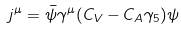Convert formula to latex. <formula><loc_0><loc_0><loc_500><loc_500>j ^ { \mu } = \bar { \psi } \gamma ^ { \mu } ( C _ { V } - C _ { A } \gamma _ { 5 } ) \psi</formula> 